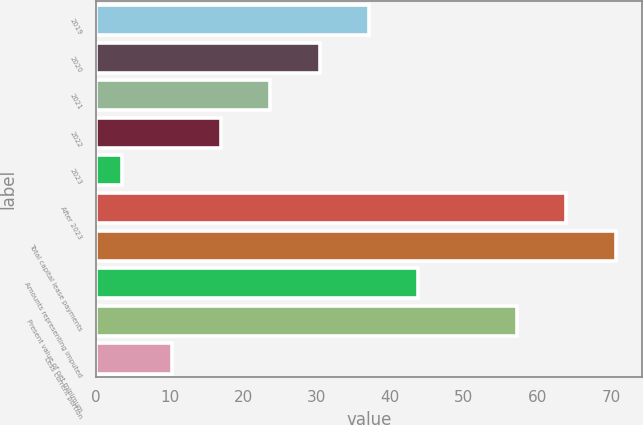Convert chart. <chart><loc_0><loc_0><loc_500><loc_500><bar_chart><fcel>2019<fcel>2020<fcel>2021<fcel>2022<fcel>2023<fcel>After 2023<fcel>Total capital lease payments<fcel>Amounts representing imputed<fcel>Present value of net minimum<fcel>Less current portion<nl><fcel>37.1<fcel>30.4<fcel>23.7<fcel>17<fcel>3.6<fcel>63.9<fcel>70.6<fcel>43.8<fcel>57.2<fcel>10.3<nl></chart> 